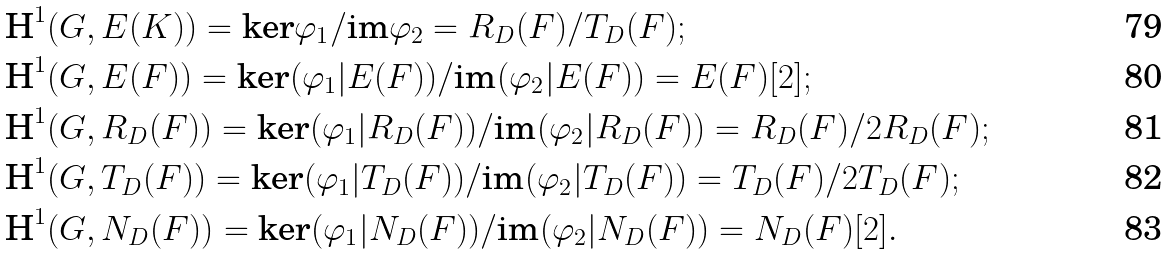Convert formula to latex. <formula><loc_0><loc_0><loc_500><loc_500>& \text {H} ^ { 1 } ( G , E ( K ) ) = \text {ker} \varphi _ { 1 } / \text {im} \varphi _ { 2 } = R _ { D } ( F ) / T _ { D } ( F ) ; \\ & \text {H} ^ { 1 } ( G , E ( F ) ) = \text {ker} ( \varphi _ { 1 } | E ( F ) ) / \text {im} ( \varphi _ { 2 } | E ( F ) ) = E ( F ) [ 2 ] ; \\ & \text {H} ^ { 1 } ( G , R _ { D } ( F ) ) = \text {ker} ( \varphi _ { 1 } | R _ { D } ( F ) ) / \text {im} ( \varphi _ { 2 } | R _ { D } ( F ) ) = R _ { D } ( F ) / 2 R _ { D } ( F ) ; \\ & \text {H} ^ { 1 } ( G , T _ { D } ( F ) ) = \text {ker} ( \varphi _ { 1 } | T _ { D } ( F ) ) / \text {im} ( \varphi _ { 2 } | T _ { D } ( F ) ) = T _ { D } ( F ) / 2 T _ { D } ( F ) ; \\ & \text {H} ^ { 1 } ( G , N _ { D } ( F ) ) = \text {ker} ( \varphi _ { 1 } | N _ { D } ( F ) ) / \text {im} ( \varphi _ { 2 } | N _ { D } ( F ) ) = N _ { D } ( F ) [ 2 ] .</formula> 